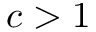Convert formula to latex. <formula><loc_0><loc_0><loc_500><loc_500>c > 1</formula> 